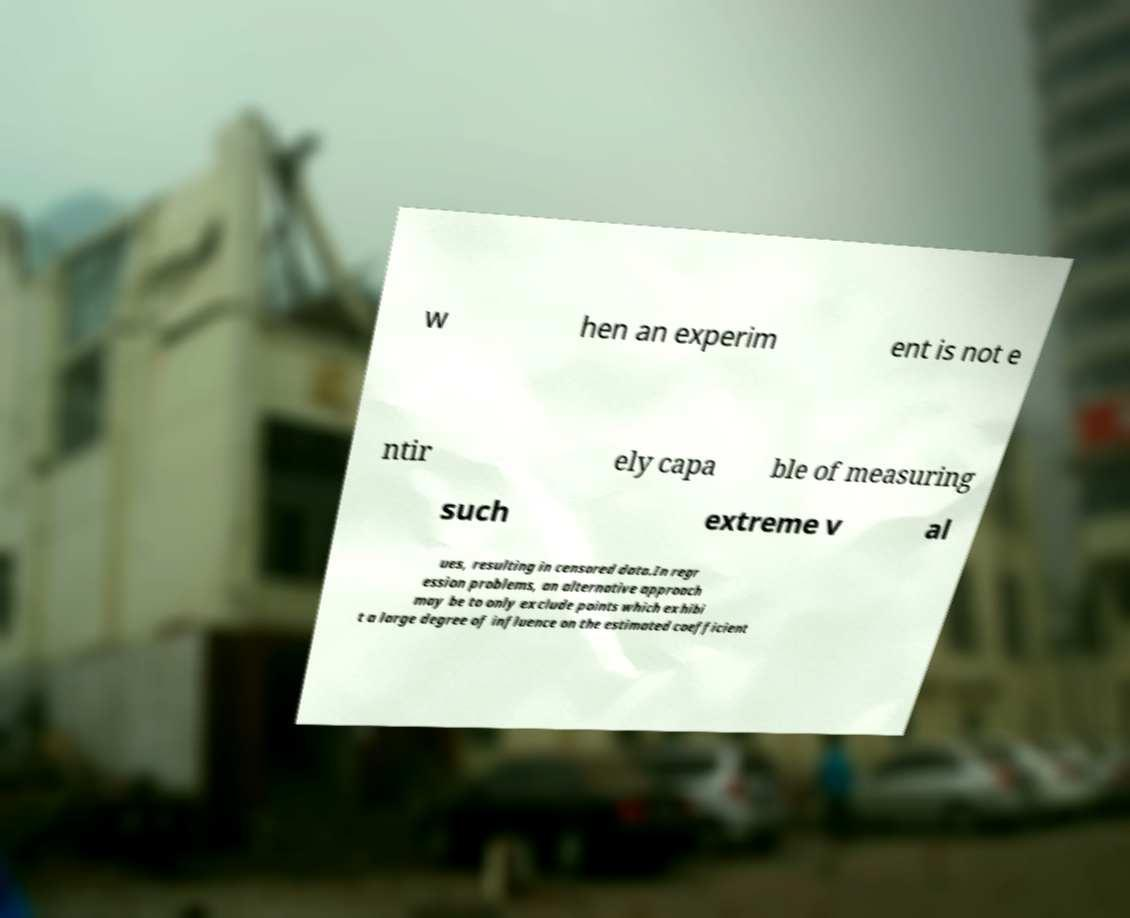For documentation purposes, I need the text within this image transcribed. Could you provide that? w hen an experim ent is not e ntir ely capa ble of measuring such extreme v al ues, resulting in censored data.In regr ession problems, an alternative approach may be to only exclude points which exhibi t a large degree of influence on the estimated coefficient 